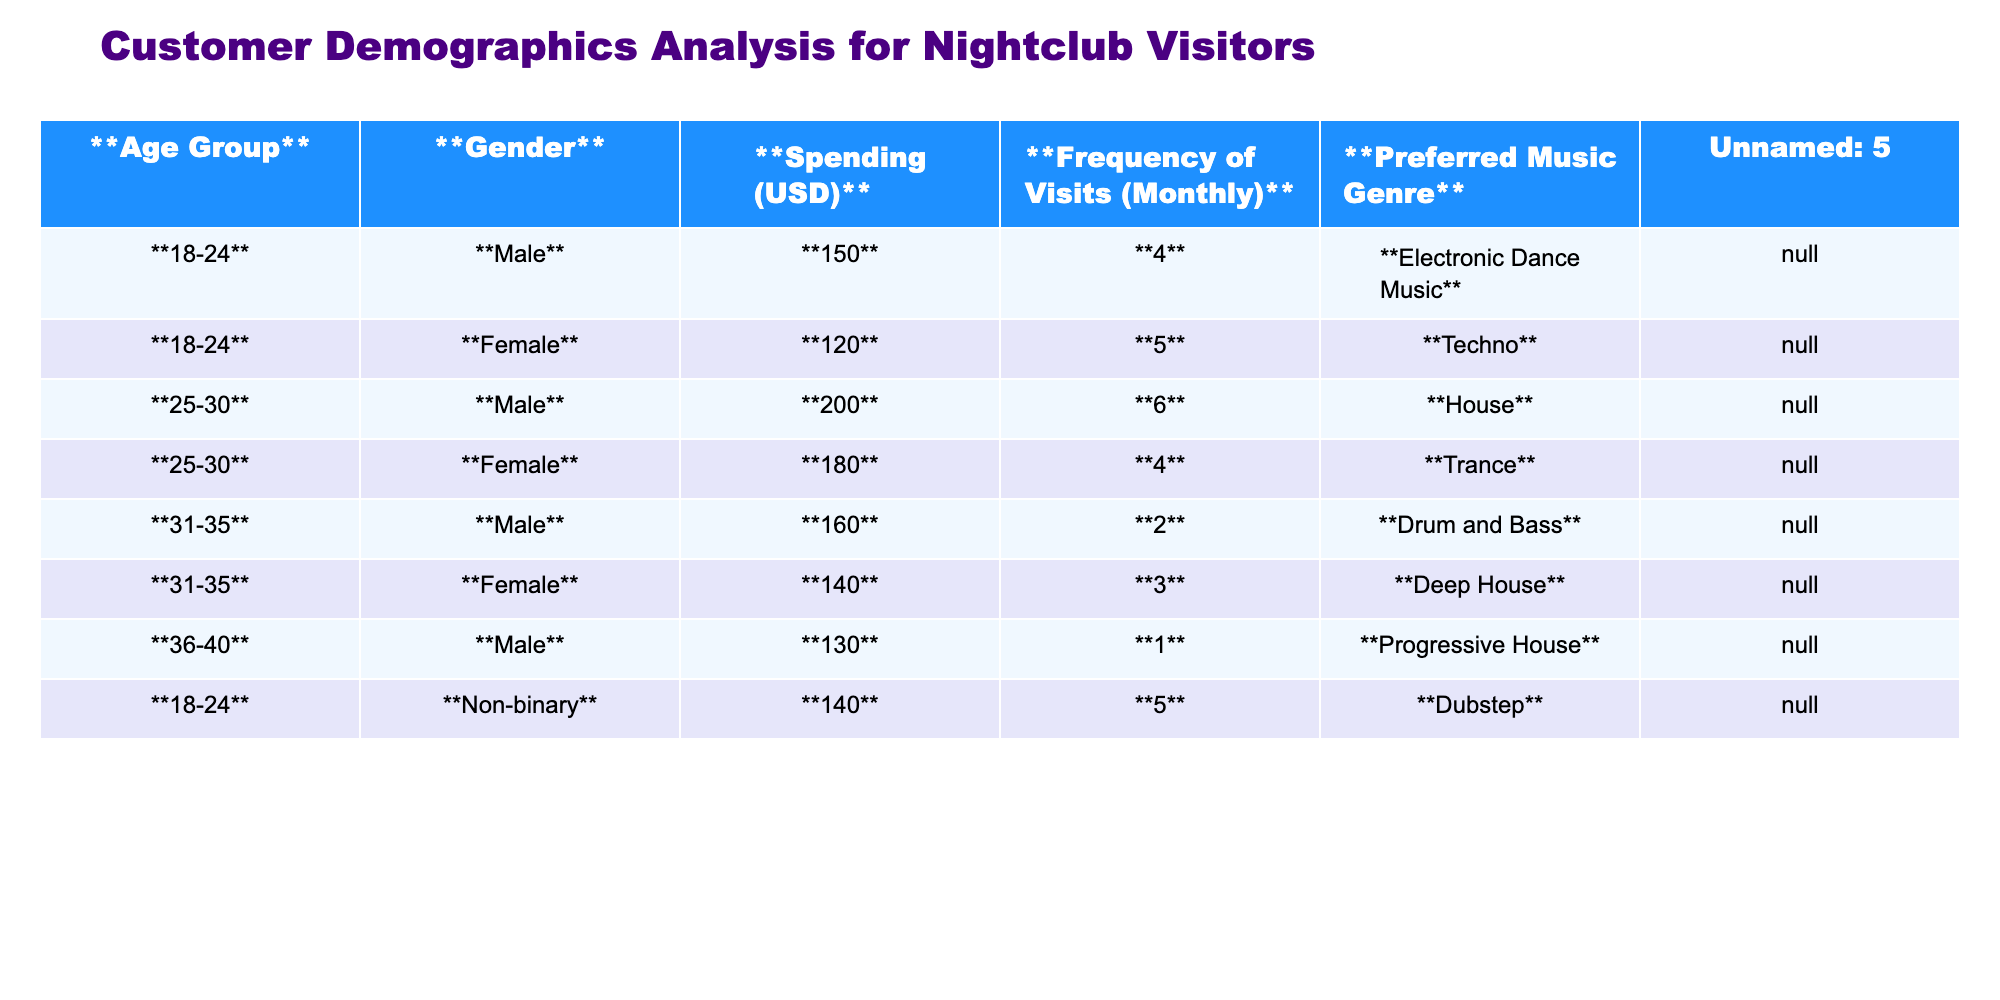What is the most popular preferred music genre among the 18-24 age group? The 18-24 age group lists "Electronic Dance Music" and "Techno" as the preferred genres. However, "Electronic Dance Music" appears only under the Male category. Thus, it is the most popular as it’s associated with higher spending and the only preference listed.
Answer: Electronic Dance Music What is the average spending of Female visitors? The spending for Female visitors is 120 (Techno) + 180 (Trance) + 140 (Deep House) = 440. There are 3 Female visitors, thus the average spending is 440/3 = 146.67, which rounds to approximately 147.
Answer: 147 Which age group has the highest frequency of visits? The 25-30 age group has a frequency of 6 visits, which is higher than any other age group listed.
Answer: 25-30 Is the average spending for Non-binary visitors greater than that for 36-40 aged Male visitors? The spending for Non-binary visitors is 140, while for 36-40 aged Male visitors it is 130. Thus, 140 > 130 is true, confirming the Non-binary visitors have higher spending.
Answer: Yes What is the total frequency of visits for all Male visitors? The total frequency for Male visitors is 4 (18-24) + 6 (25-30) + 2 (31-35) + 1 (36-40) = 13 visits.
Answer: 13 Which gender spends the least on average? Male visitors average spending is (150 + 200 + 160 + 130)/4 = 160. Female visitors average spending is (120 + 180 + 140)/3 = 146.67. Non-binary visitor has a spending of 140. Thus, Female visitors have the least, rounded down to approximately 147.
Answer: Female How many visitors prefer Electronic Dance Music? Only the Male in the 18-24 age group prefers Electronic Dance Music. Counting the Male leads to 1 visitor total here.
Answer: 1 What is the combined spending of the 25-30 age group? The combined spending for the 25-30 age group is 200 (Male) + 180 (Female) = 380.
Answer: 380 Which age group has the highest average spending? The 25-30 age group. Calculating, average (200 + 180)/2 = 190 which is higher than other age groups.
Answer: 25-30 Do more Male visitors prefer House than Female visitors prefer Trance? Yes, there’s only one Male visitor that prefers House, while only one Female visitor prefers Trance, so the numbers equate to one; hence the fact is untrue.
Answer: No 